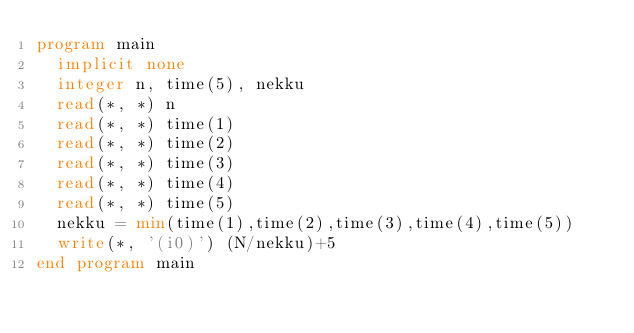<code> <loc_0><loc_0><loc_500><loc_500><_FORTRAN_>program main
  implicit none
  integer n, time(5), nekku
  read(*, *) n
  read(*, *) time(1)
  read(*, *) time(2)
  read(*, *) time(3)
  read(*, *) time(4)
  read(*, *) time(5)
  nekku = min(time(1),time(2),time(3),time(4),time(5))
  write(*, '(i0)') (N/nekku)+5
end program main</code> 